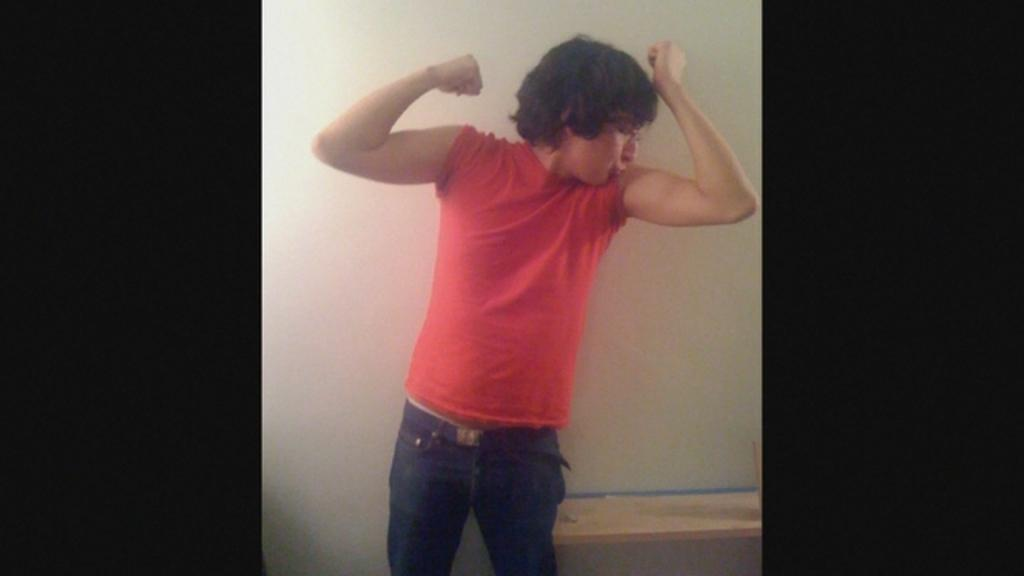What is the main subject of the image? There is a man standing in the center of the image. Can you describe the background of the image? There is a wall in the background of the image. What type of drug can be seen in the image? There is no drug present in the image; it features a man standing in front of a wall. 